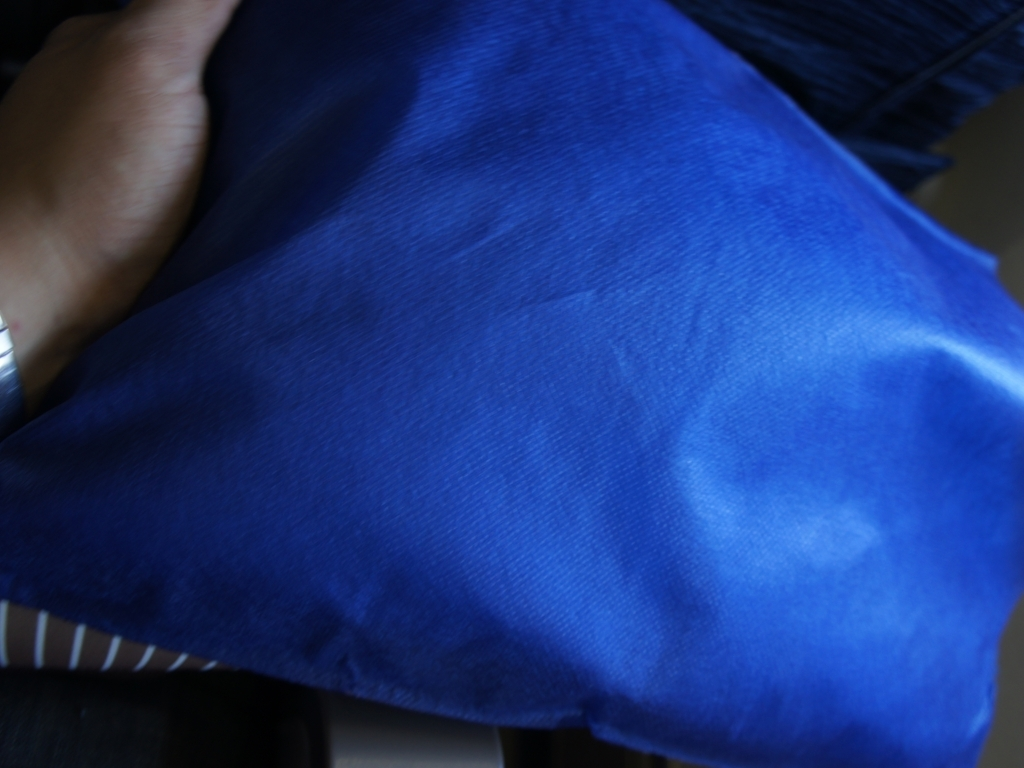Is there anything in the image that provides a hint about the setting or context in which this photo was taken? The setting is not clearly defined due to the blurred background, but the visible striped pattern suggests that the cushion may be on a sofa or indoor furniture, implying a domestic environment. Given the focus quality, what might have prompted the photographer to capture this image? The photograph could be an impromptu capture, possibly highlighting the texture and color of the cushion as an element of interior design or for online sales. The lack of focus might be unintended or could be an artistic choice to draw attention to the texture of the fabric. 